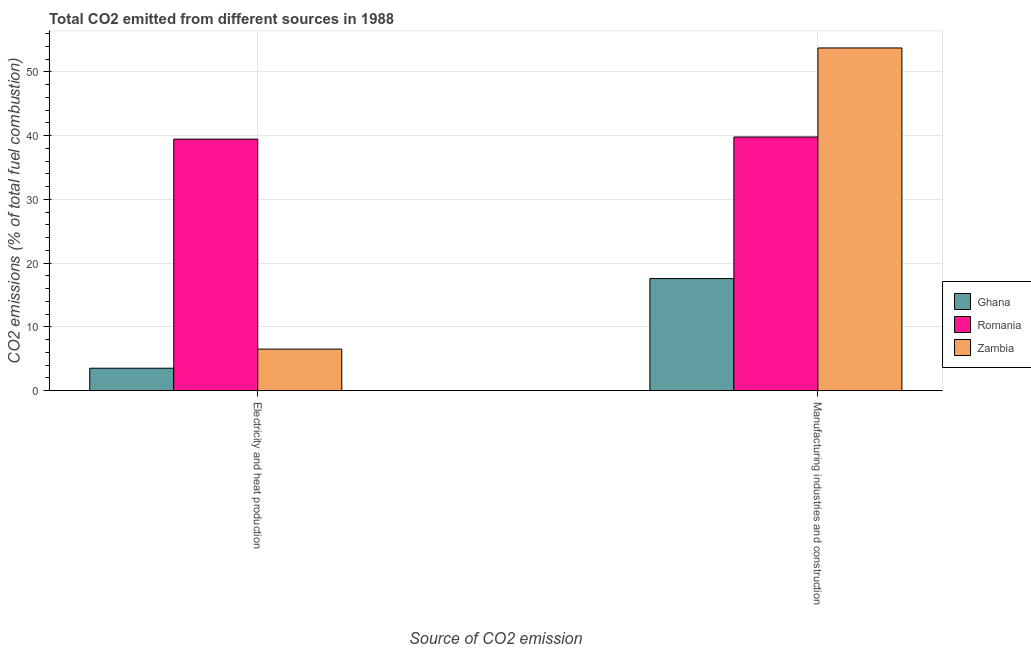How many different coloured bars are there?
Give a very brief answer. 3. How many bars are there on the 1st tick from the right?
Keep it short and to the point. 3. What is the label of the 2nd group of bars from the left?
Keep it short and to the point. Manufacturing industries and construction. What is the co2 emissions due to manufacturing industries in Romania?
Provide a short and direct response. 39.79. Across all countries, what is the maximum co2 emissions due to manufacturing industries?
Provide a succinct answer. 53.75. Across all countries, what is the minimum co2 emissions due to electricity and heat production?
Your response must be concise. 3.52. In which country was the co2 emissions due to electricity and heat production maximum?
Provide a short and direct response. Romania. In which country was the co2 emissions due to electricity and heat production minimum?
Make the answer very short. Ghana. What is the total co2 emissions due to manufacturing industries in the graph?
Offer a very short reply. 111.11. What is the difference between the co2 emissions due to manufacturing industries in Romania and that in Zambia?
Keep it short and to the point. -13.96. What is the difference between the co2 emissions due to manufacturing industries in Ghana and the co2 emissions due to electricity and heat production in Romania?
Give a very brief answer. -21.87. What is the average co2 emissions due to manufacturing industries per country?
Keep it short and to the point. 37.04. What is the difference between the co2 emissions due to electricity and heat production and co2 emissions due to manufacturing industries in Zambia?
Make the answer very short. -47.23. In how many countries, is the co2 emissions due to manufacturing industries greater than 32 %?
Provide a short and direct response. 2. What is the ratio of the co2 emissions due to electricity and heat production in Ghana to that in Romania?
Provide a succinct answer. 0.09. Is the co2 emissions due to electricity and heat production in Romania less than that in Zambia?
Give a very brief answer. No. In how many countries, is the co2 emissions due to electricity and heat production greater than the average co2 emissions due to electricity and heat production taken over all countries?
Ensure brevity in your answer.  1. What does the 2nd bar from the right in Manufacturing industries and construction represents?
Make the answer very short. Romania. How many bars are there?
Your response must be concise. 6. Are all the bars in the graph horizontal?
Offer a very short reply. No. How many countries are there in the graph?
Make the answer very short. 3. What is the difference between two consecutive major ticks on the Y-axis?
Your response must be concise. 10. Where does the legend appear in the graph?
Make the answer very short. Center right. How many legend labels are there?
Give a very brief answer. 3. How are the legend labels stacked?
Keep it short and to the point. Vertical. What is the title of the graph?
Keep it short and to the point. Total CO2 emitted from different sources in 1988. What is the label or title of the X-axis?
Keep it short and to the point. Source of CO2 emission. What is the label or title of the Y-axis?
Keep it short and to the point. CO2 emissions (% of total fuel combustion). What is the CO2 emissions (% of total fuel combustion) of Ghana in Electricity and heat production?
Keep it short and to the point. 3.52. What is the CO2 emissions (% of total fuel combustion) of Romania in Electricity and heat production?
Provide a short and direct response. 39.45. What is the CO2 emissions (% of total fuel combustion) in Zambia in Electricity and heat production?
Offer a very short reply. 6.51. What is the CO2 emissions (% of total fuel combustion) in Ghana in Manufacturing industries and construction?
Offer a very short reply. 17.58. What is the CO2 emissions (% of total fuel combustion) in Romania in Manufacturing industries and construction?
Offer a terse response. 39.79. What is the CO2 emissions (% of total fuel combustion) in Zambia in Manufacturing industries and construction?
Your answer should be compact. 53.75. Across all Source of CO2 emission, what is the maximum CO2 emissions (% of total fuel combustion) of Ghana?
Give a very brief answer. 17.58. Across all Source of CO2 emission, what is the maximum CO2 emissions (% of total fuel combustion) of Romania?
Your answer should be compact. 39.79. Across all Source of CO2 emission, what is the maximum CO2 emissions (% of total fuel combustion) of Zambia?
Make the answer very short. 53.75. Across all Source of CO2 emission, what is the minimum CO2 emissions (% of total fuel combustion) in Ghana?
Provide a short and direct response. 3.52. Across all Source of CO2 emission, what is the minimum CO2 emissions (% of total fuel combustion) in Romania?
Your answer should be compact. 39.45. Across all Source of CO2 emission, what is the minimum CO2 emissions (% of total fuel combustion) of Zambia?
Offer a very short reply. 6.51. What is the total CO2 emissions (% of total fuel combustion) of Ghana in the graph?
Offer a very short reply. 21.09. What is the total CO2 emissions (% of total fuel combustion) of Romania in the graph?
Your response must be concise. 79.23. What is the total CO2 emissions (% of total fuel combustion) of Zambia in the graph?
Keep it short and to the point. 60.26. What is the difference between the CO2 emissions (% of total fuel combustion) in Ghana in Electricity and heat production and that in Manufacturing industries and construction?
Your answer should be very brief. -14.06. What is the difference between the CO2 emissions (% of total fuel combustion) of Romania in Electricity and heat production and that in Manufacturing industries and construction?
Your answer should be compact. -0.34. What is the difference between the CO2 emissions (% of total fuel combustion) of Zambia in Electricity and heat production and that in Manufacturing industries and construction?
Offer a very short reply. -47.23. What is the difference between the CO2 emissions (% of total fuel combustion) in Ghana in Electricity and heat production and the CO2 emissions (% of total fuel combustion) in Romania in Manufacturing industries and construction?
Offer a terse response. -36.27. What is the difference between the CO2 emissions (% of total fuel combustion) in Ghana in Electricity and heat production and the CO2 emissions (% of total fuel combustion) in Zambia in Manufacturing industries and construction?
Provide a short and direct response. -50.23. What is the difference between the CO2 emissions (% of total fuel combustion) of Romania in Electricity and heat production and the CO2 emissions (% of total fuel combustion) of Zambia in Manufacturing industries and construction?
Your answer should be very brief. -14.3. What is the average CO2 emissions (% of total fuel combustion) in Ghana per Source of CO2 emission?
Offer a very short reply. 10.55. What is the average CO2 emissions (% of total fuel combustion) of Romania per Source of CO2 emission?
Your answer should be very brief. 39.62. What is the average CO2 emissions (% of total fuel combustion) of Zambia per Source of CO2 emission?
Ensure brevity in your answer.  30.13. What is the difference between the CO2 emissions (% of total fuel combustion) in Ghana and CO2 emissions (% of total fuel combustion) in Romania in Electricity and heat production?
Offer a very short reply. -35.93. What is the difference between the CO2 emissions (% of total fuel combustion) of Ghana and CO2 emissions (% of total fuel combustion) of Zambia in Electricity and heat production?
Keep it short and to the point. -3. What is the difference between the CO2 emissions (% of total fuel combustion) in Romania and CO2 emissions (% of total fuel combustion) in Zambia in Electricity and heat production?
Provide a succinct answer. 32.93. What is the difference between the CO2 emissions (% of total fuel combustion) in Ghana and CO2 emissions (% of total fuel combustion) in Romania in Manufacturing industries and construction?
Your response must be concise. -22.21. What is the difference between the CO2 emissions (% of total fuel combustion) in Ghana and CO2 emissions (% of total fuel combustion) in Zambia in Manufacturing industries and construction?
Provide a short and direct response. -36.17. What is the difference between the CO2 emissions (% of total fuel combustion) in Romania and CO2 emissions (% of total fuel combustion) in Zambia in Manufacturing industries and construction?
Your answer should be very brief. -13.96. What is the ratio of the CO2 emissions (% of total fuel combustion) in Romania in Electricity and heat production to that in Manufacturing industries and construction?
Offer a very short reply. 0.99. What is the ratio of the CO2 emissions (% of total fuel combustion) in Zambia in Electricity and heat production to that in Manufacturing industries and construction?
Your answer should be compact. 0.12. What is the difference between the highest and the second highest CO2 emissions (% of total fuel combustion) in Ghana?
Offer a very short reply. 14.06. What is the difference between the highest and the second highest CO2 emissions (% of total fuel combustion) of Romania?
Provide a succinct answer. 0.34. What is the difference between the highest and the second highest CO2 emissions (% of total fuel combustion) of Zambia?
Provide a succinct answer. 47.23. What is the difference between the highest and the lowest CO2 emissions (% of total fuel combustion) of Ghana?
Offer a very short reply. 14.06. What is the difference between the highest and the lowest CO2 emissions (% of total fuel combustion) of Romania?
Keep it short and to the point. 0.34. What is the difference between the highest and the lowest CO2 emissions (% of total fuel combustion) in Zambia?
Provide a short and direct response. 47.23. 